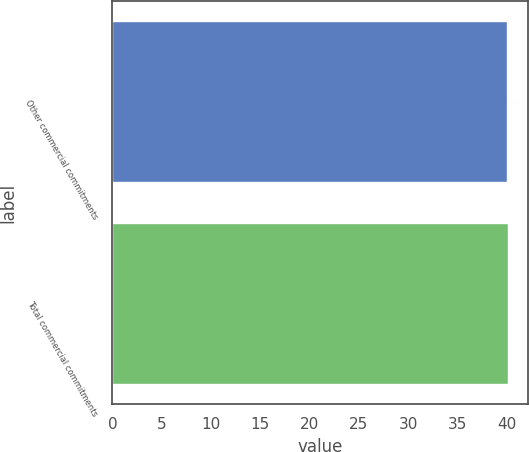<chart> <loc_0><loc_0><loc_500><loc_500><bar_chart><fcel>Other commercial commitments<fcel>Total commercial commitments<nl><fcel>40<fcel>40.1<nl></chart> 